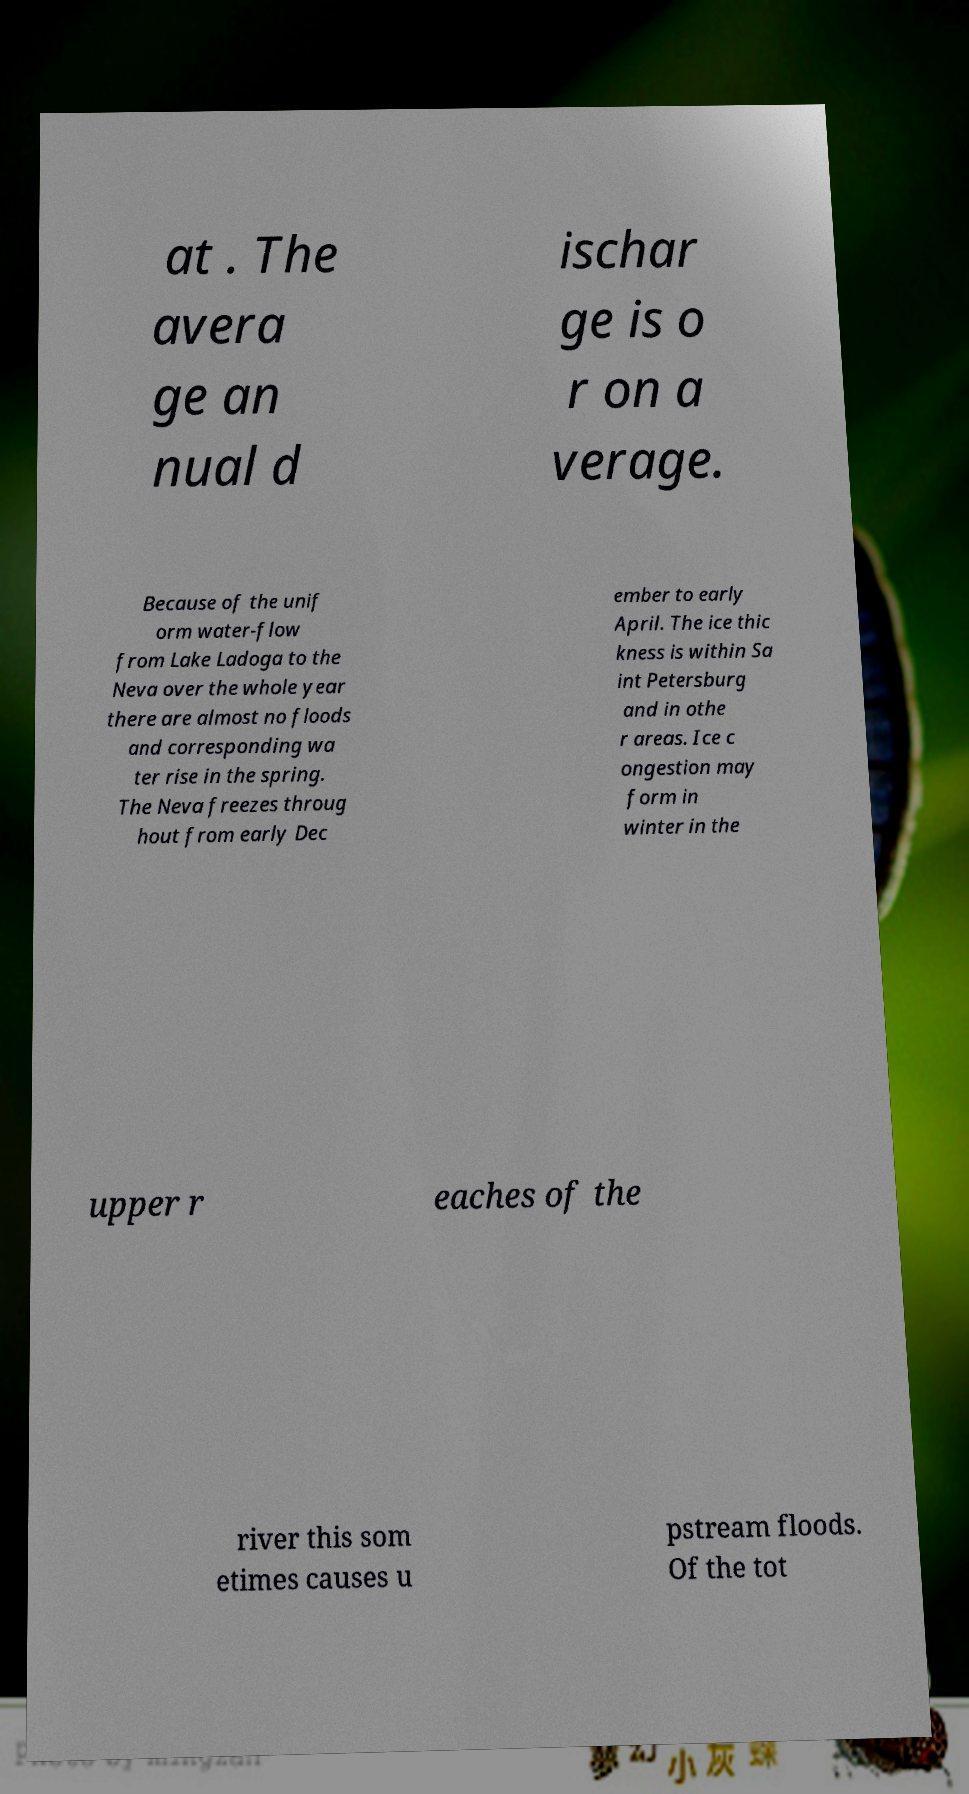Can you accurately transcribe the text from the provided image for me? at . The avera ge an nual d ischar ge is o r on a verage. Because of the unif orm water-flow from Lake Ladoga to the Neva over the whole year there are almost no floods and corresponding wa ter rise in the spring. The Neva freezes throug hout from early Dec ember to early April. The ice thic kness is within Sa int Petersburg and in othe r areas. Ice c ongestion may form in winter in the upper r eaches of the river this som etimes causes u pstream floods. Of the tot 